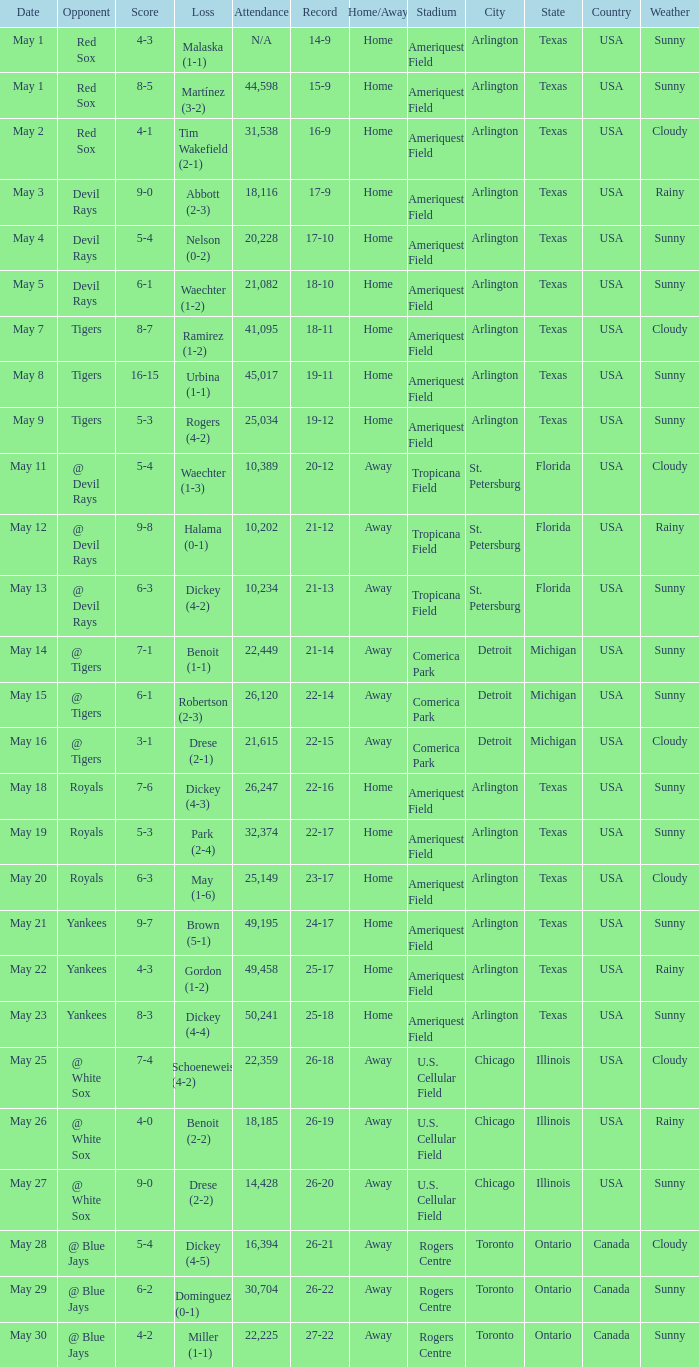What was the score of the game that had a loss of Drese (2-2)? 9-0. 